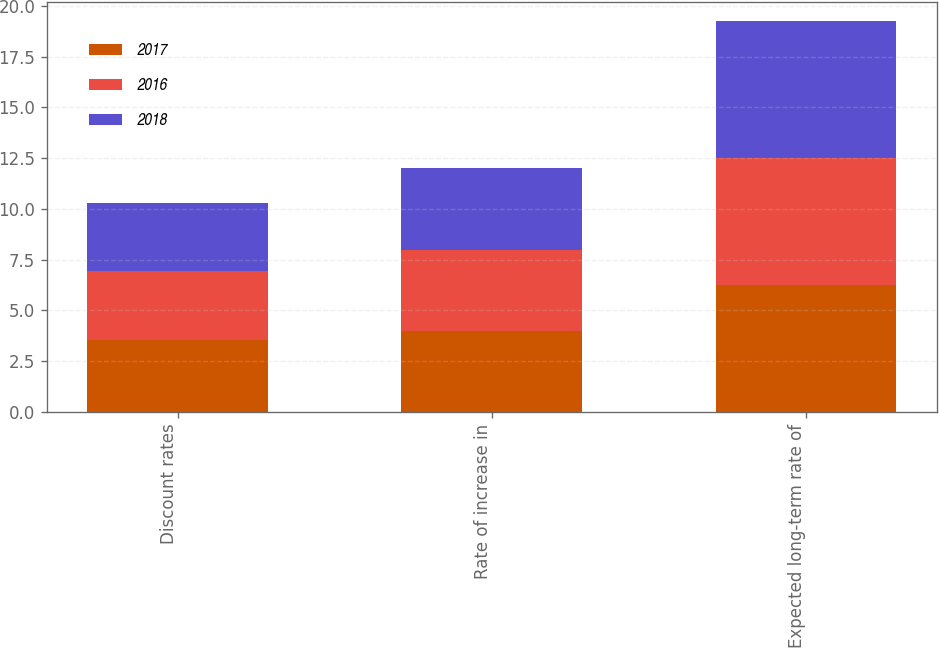<chart> <loc_0><loc_0><loc_500><loc_500><stacked_bar_chart><ecel><fcel>Discount rates<fcel>Rate of increase in<fcel>Expected long-term rate of<nl><fcel>2017<fcel>3.55<fcel>4<fcel>6.25<nl><fcel>2016<fcel>3.4<fcel>4<fcel>6.25<nl><fcel>2018<fcel>3.36<fcel>4<fcel>6.75<nl></chart> 